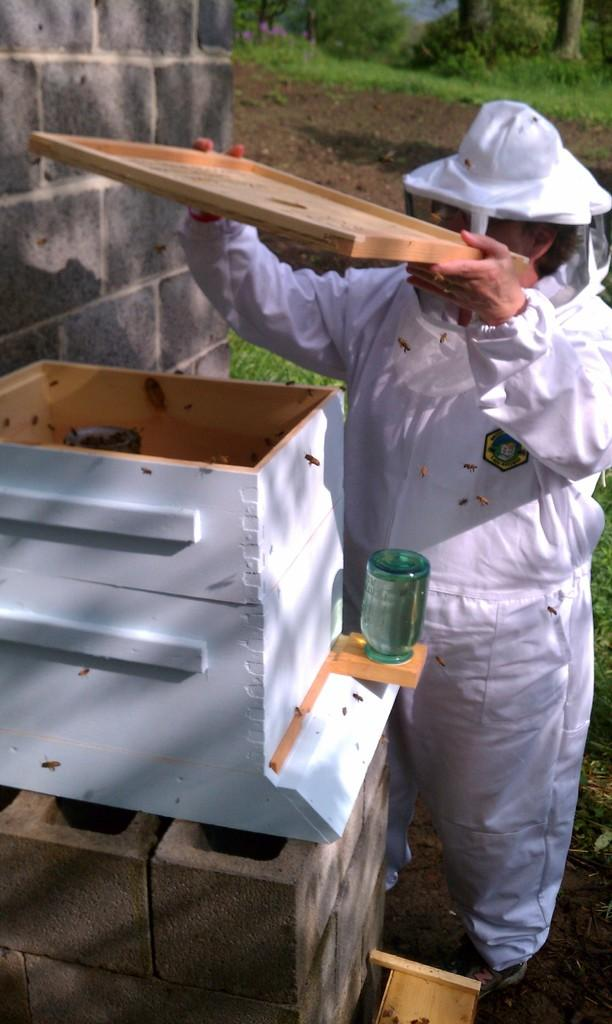Who is present in the image? There is a person in the image. What is the person wearing? The person is wearing a white dress. What is the person doing in the image? The person is looking into a box. What object is the person interacting with? There is a box in the image. What is visible on the left side of the image? There is a wall on the left side of the image. What type of cake is being served to the visitor in the image? There is no cake or visitor present in the image. What liquid is being poured into the box by the person in the image? There is no liquid or pouring action depicted in the image. 